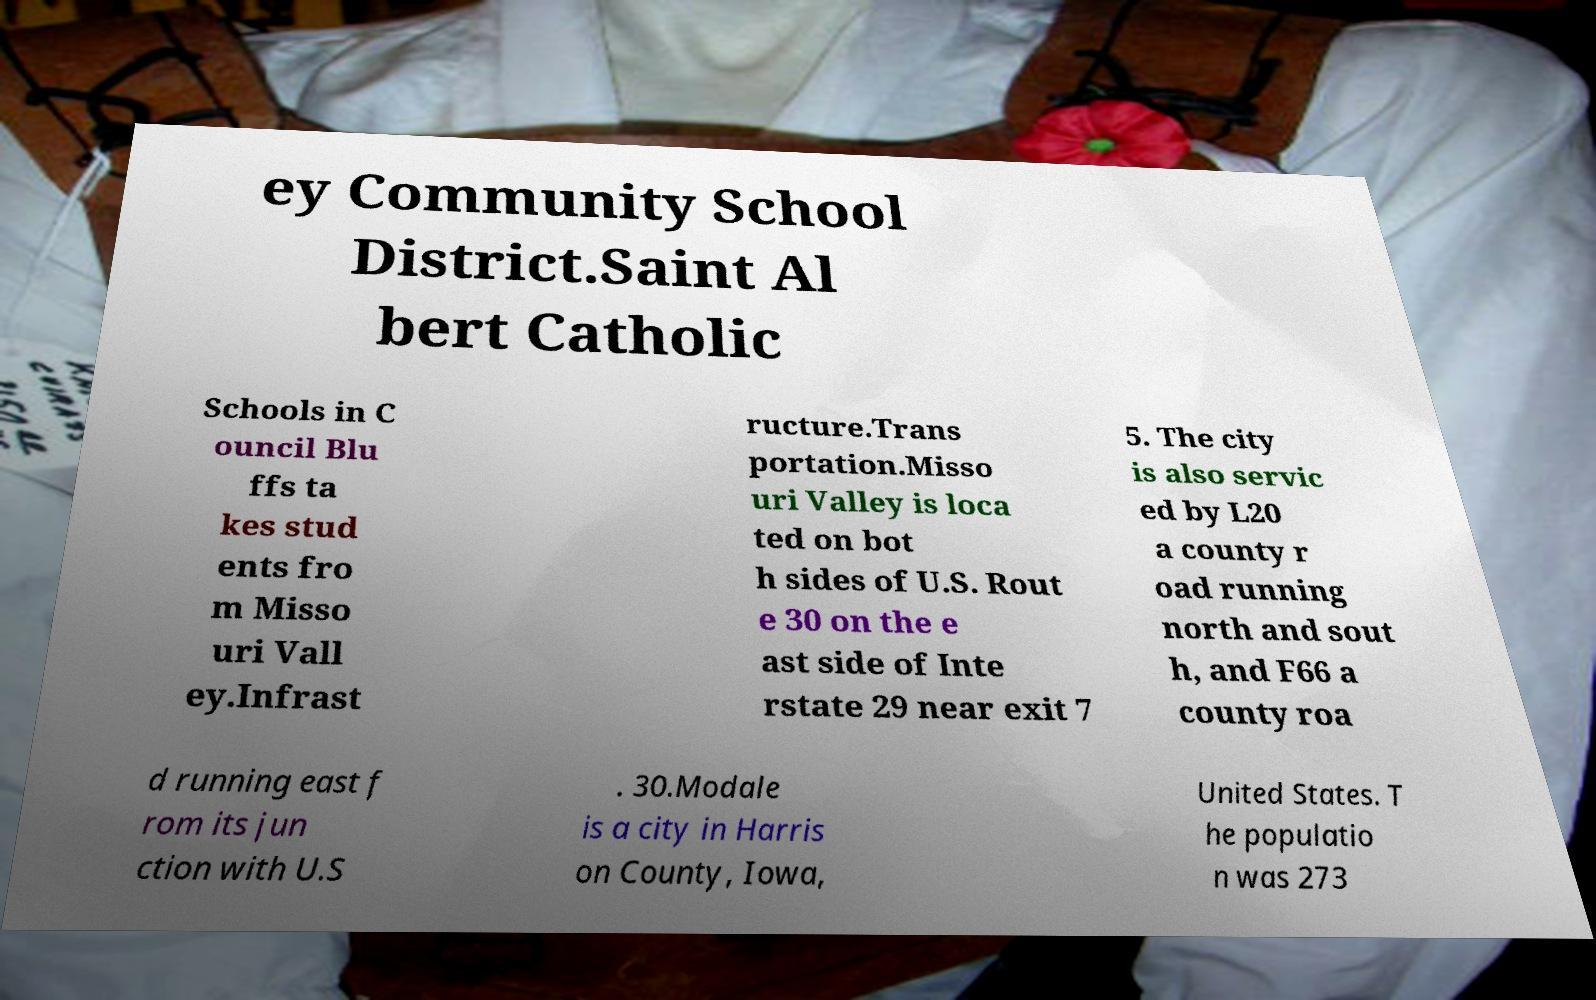What messages or text are displayed in this image? I need them in a readable, typed format. ey Community School District.Saint Al bert Catholic Schools in C ouncil Blu ffs ta kes stud ents fro m Misso uri Vall ey.Infrast ructure.Trans portation.Misso uri Valley is loca ted on bot h sides of U.S. Rout e 30 on the e ast side of Inte rstate 29 near exit 7 5. The city is also servic ed by L20 a county r oad running north and sout h, and F66 a county roa d running east f rom its jun ction with U.S . 30.Modale is a city in Harris on County, Iowa, United States. T he populatio n was 273 